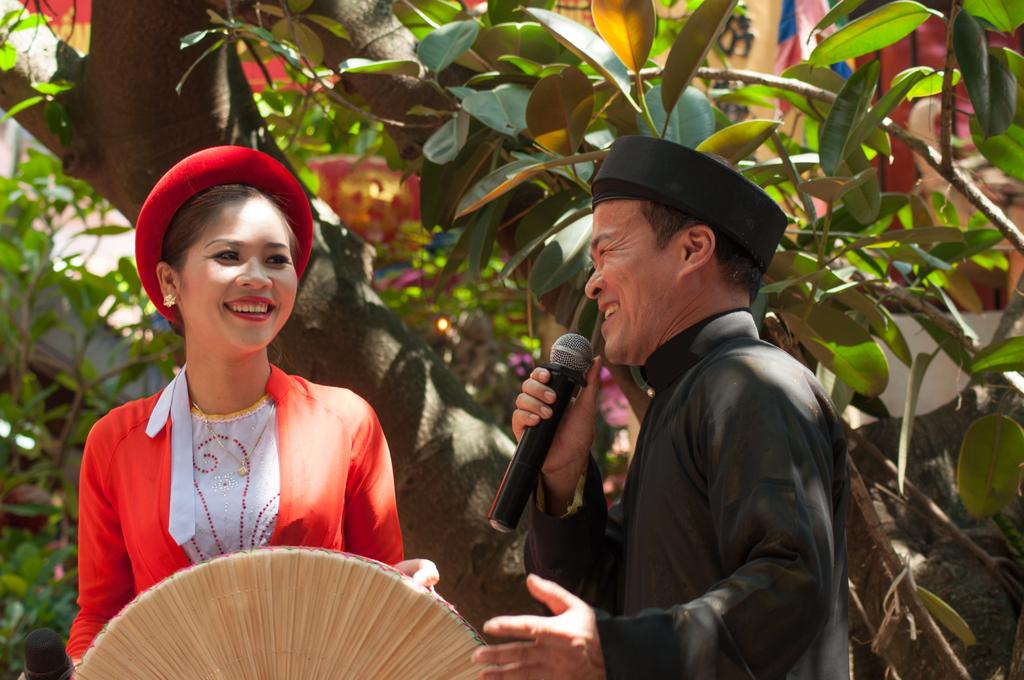What is the man in the image holding? The man is holding a microphone. Who else is present in the image? There is a woman in the image. What can be seen in the background of the image? There are trees in the image. What type of jam is being spread on the snake in the image? There is no jam or snake present in the image. 